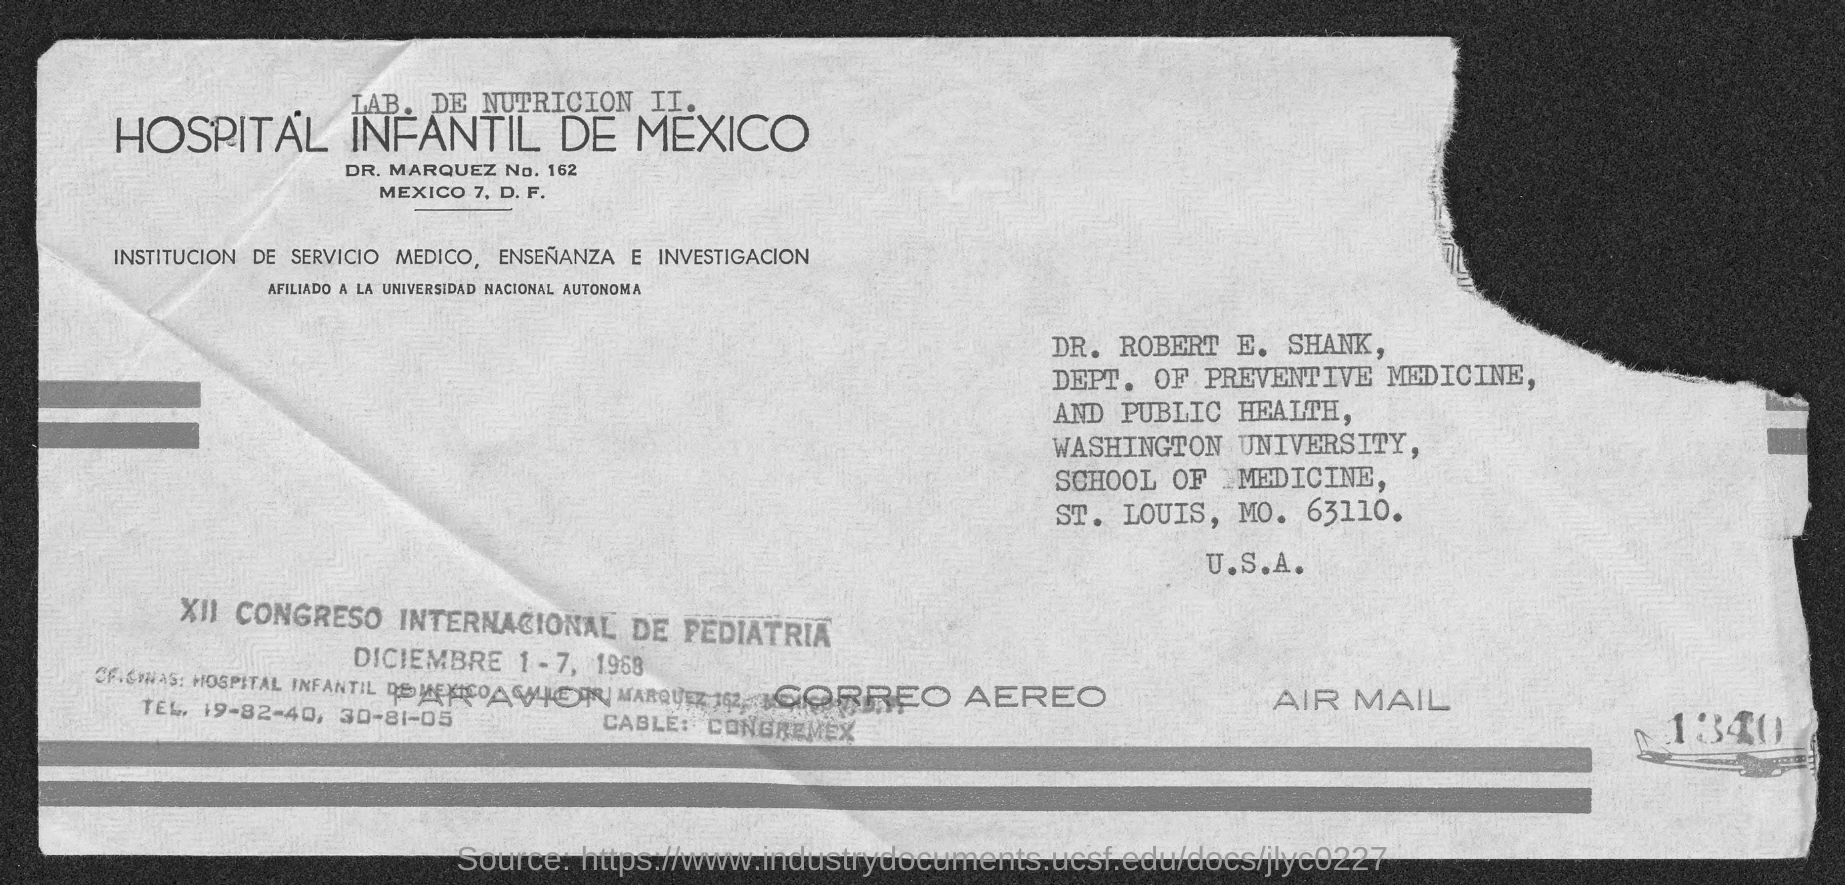To Whom is this letter addressed to?
Your answer should be very brief. Dr. Robert E. Shank. 